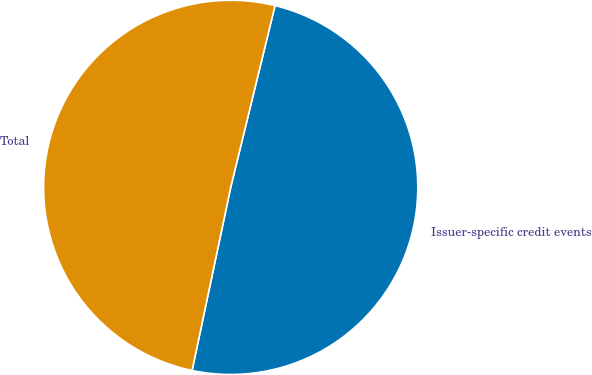Convert chart. <chart><loc_0><loc_0><loc_500><loc_500><pie_chart><fcel>Issuer-specific credit events<fcel>Total<nl><fcel>49.5%<fcel>50.5%<nl></chart> 